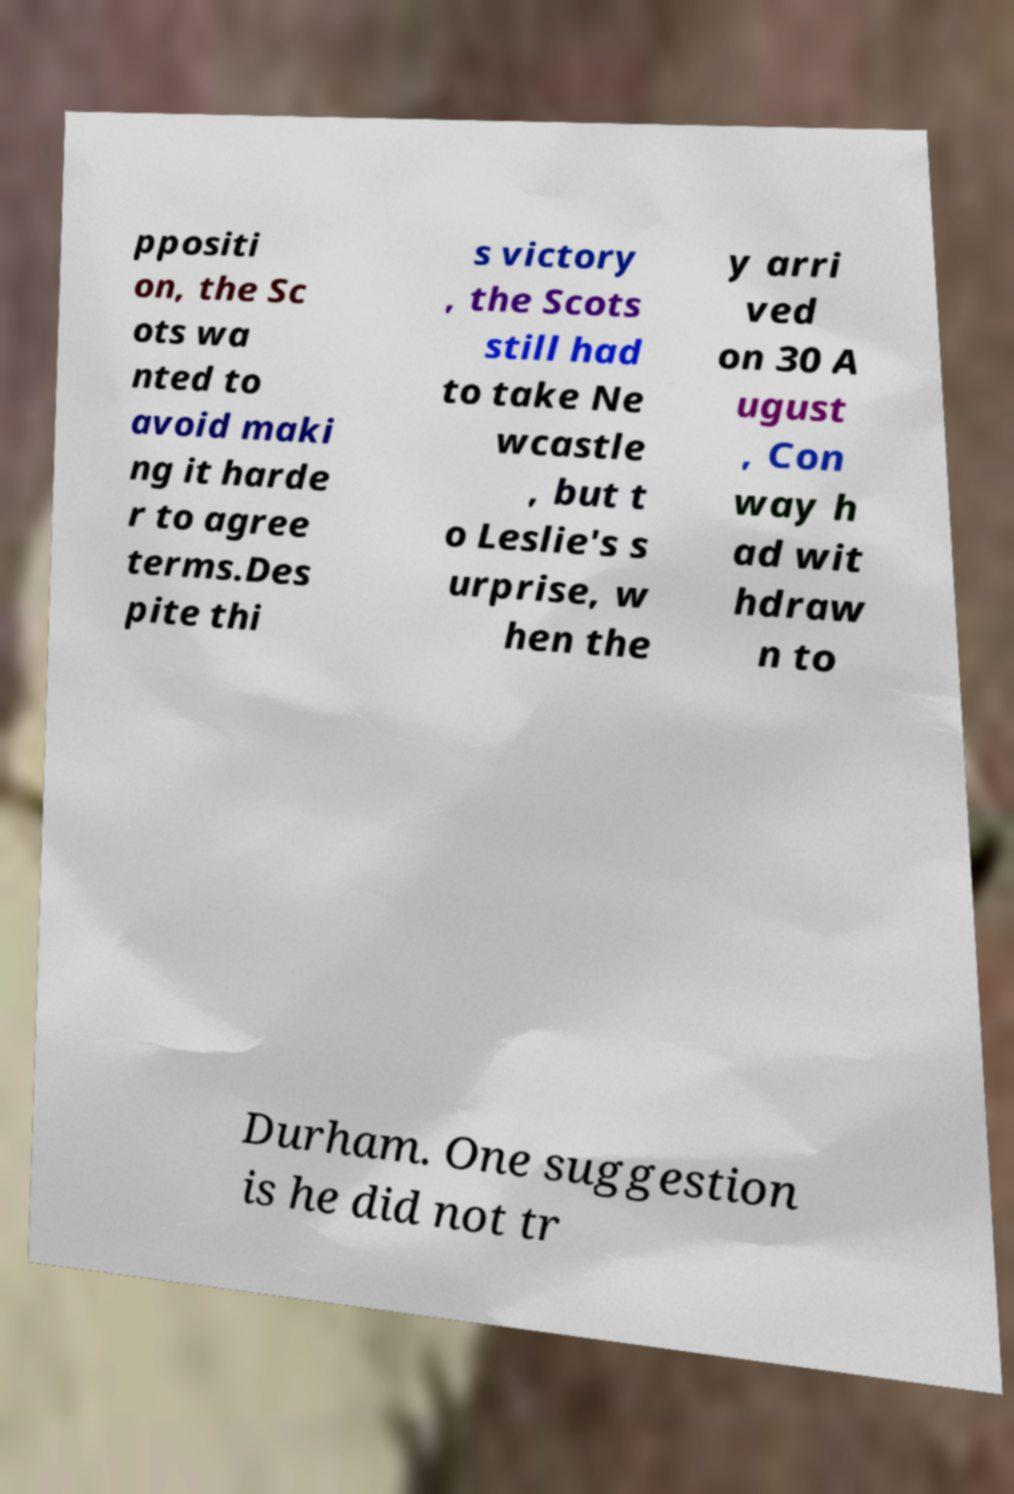There's text embedded in this image that I need extracted. Can you transcribe it verbatim? ppositi on, the Sc ots wa nted to avoid maki ng it harde r to agree terms.Des pite thi s victory , the Scots still had to take Ne wcastle , but t o Leslie's s urprise, w hen the y arri ved on 30 A ugust , Con way h ad wit hdraw n to Durham. One suggestion is he did not tr 